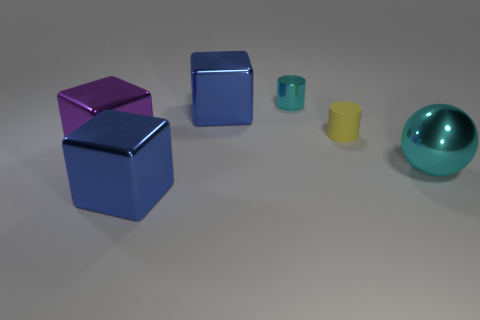Subtract all brown cylinders. Subtract all red blocks. How many cylinders are left? 2 Subtract all purple cylinders. How many purple balls are left? 0 Add 3 big browns. How many big things exist? 0 Subtract all small purple matte cubes. Subtract all large purple blocks. How many objects are left? 5 Add 3 spheres. How many spheres are left? 4 Add 3 red things. How many red things exist? 3 Add 1 big metal things. How many objects exist? 7 Subtract all purple blocks. How many blocks are left? 2 Subtract all blue cubes. How many cubes are left? 1 Subtract 0 red cylinders. How many objects are left? 6 